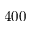Convert formula to latex. <formula><loc_0><loc_0><loc_500><loc_500>4 0 0</formula> 